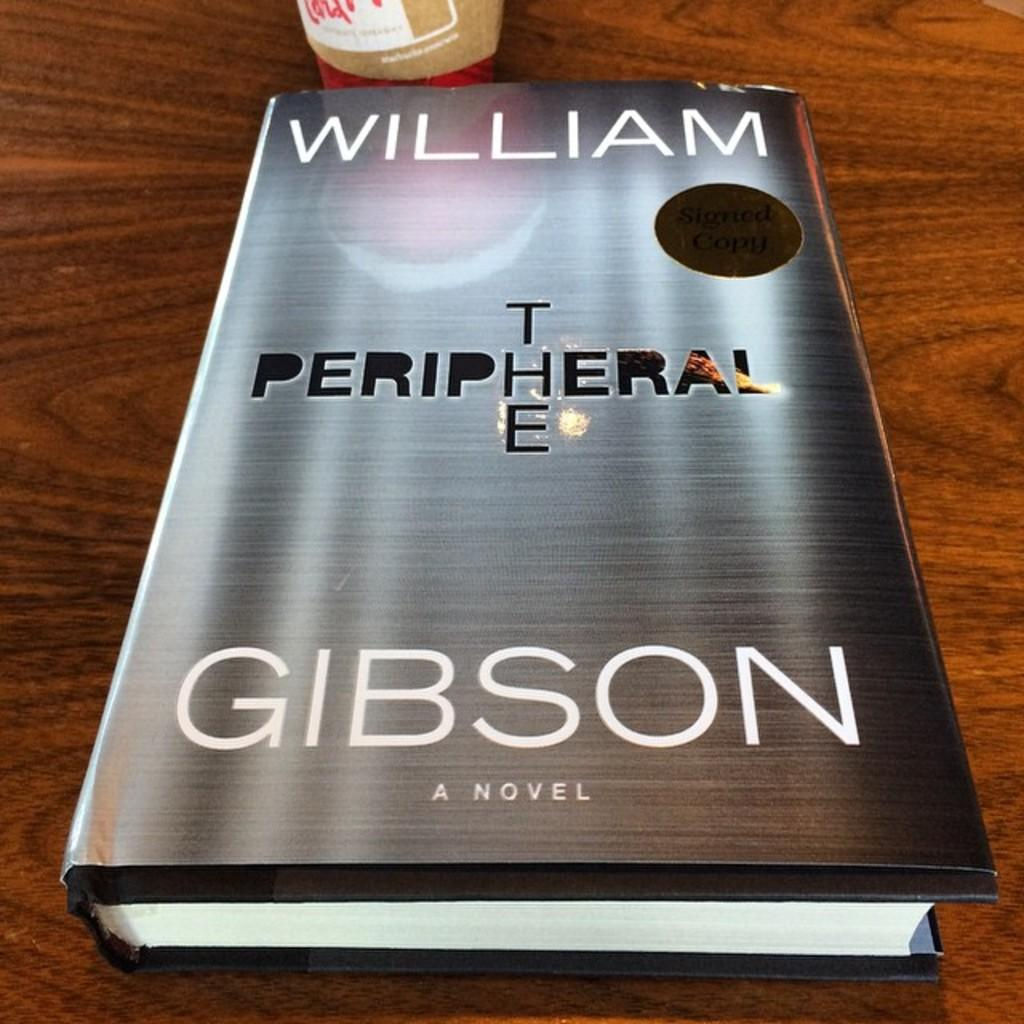<image>
Provide a brief description of the given image. A book by William Gibson called The Peripheral lying on a wood table. 